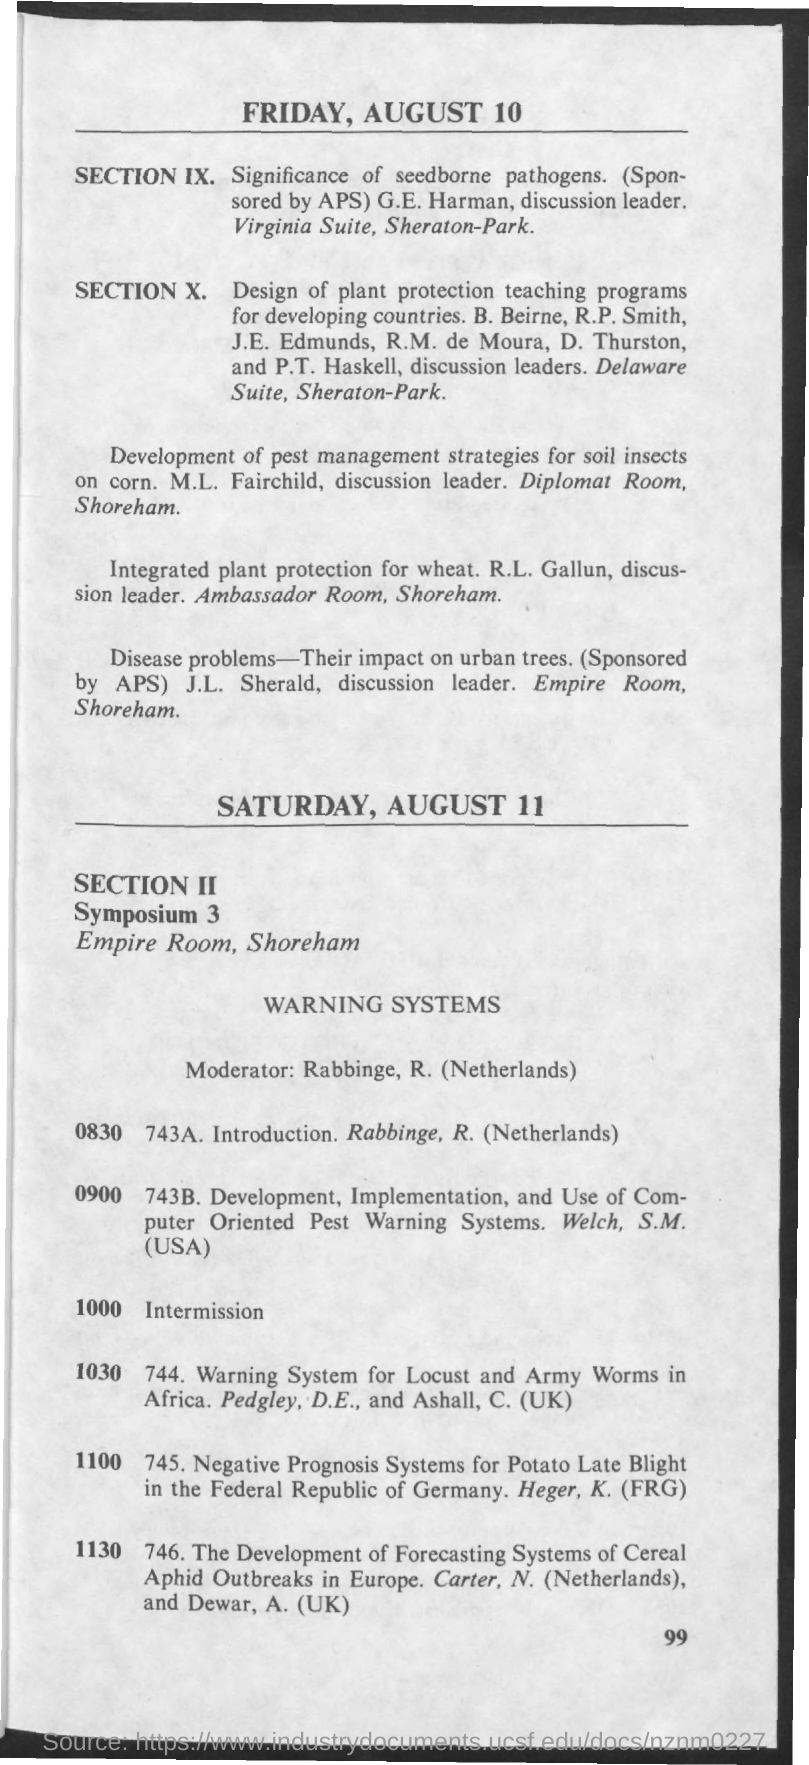Outline some significant characteristics in this image. The date mentioned in the given page is Friday, August 10. The name of the room for Symposium 3 is the Empire Room. 